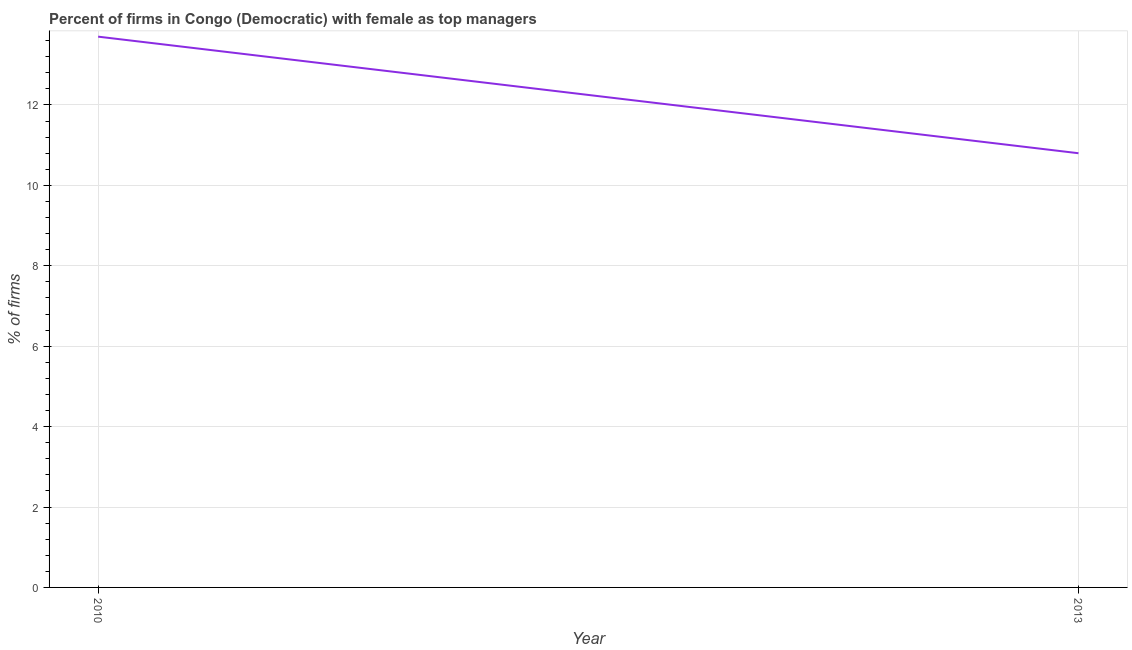Across all years, what is the minimum percentage of firms with female as top manager?
Your answer should be compact. 10.8. What is the sum of the percentage of firms with female as top manager?
Keep it short and to the point. 24.5. What is the difference between the percentage of firms with female as top manager in 2010 and 2013?
Make the answer very short. 2.9. What is the average percentage of firms with female as top manager per year?
Offer a very short reply. 12.25. What is the median percentage of firms with female as top manager?
Make the answer very short. 12.25. In how many years, is the percentage of firms with female as top manager greater than 0.4 %?
Your answer should be compact. 2. Do a majority of the years between 2013 and 2010 (inclusive) have percentage of firms with female as top manager greater than 6.4 %?
Provide a succinct answer. No. What is the ratio of the percentage of firms with female as top manager in 2010 to that in 2013?
Offer a very short reply. 1.27. How many lines are there?
Give a very brief answer. 1. What is the difference between two consecutive major ticks on the Y-axis?
Give a very brief answer. 2. What is the title of the graph?
Keep it short and to the point. Percent of firms in Congo (Democratic) with female as top managers. What is the label or title of the Y-axis?
Your answer should be compact. % of firms. What is the % of firms in 2013?
Your answer should be compact. 10.8. What is the ratio of the % of firms in 2010 to that in 2013?
Offer a terse response. 1.27. 